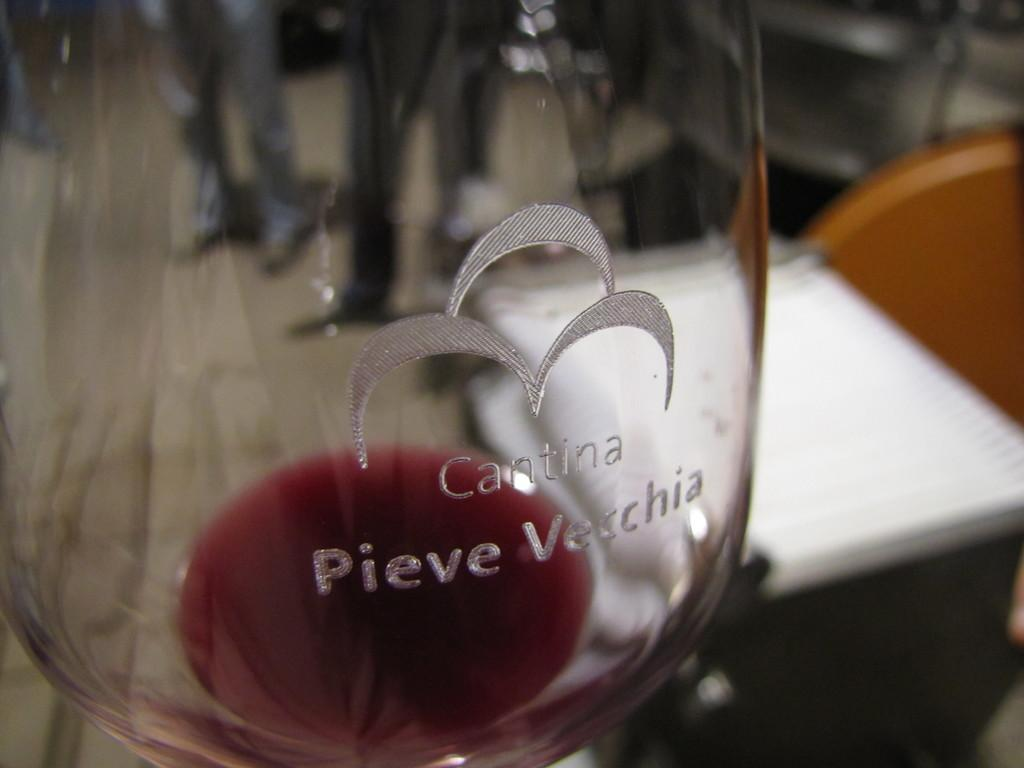<image>
Summarize the visual content of the image. A near empty wine glass that says Cantina Pieve Vecchia on it 